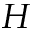<formula> <loc_0><loc_0><loc_500><loc_500>H</formula> 